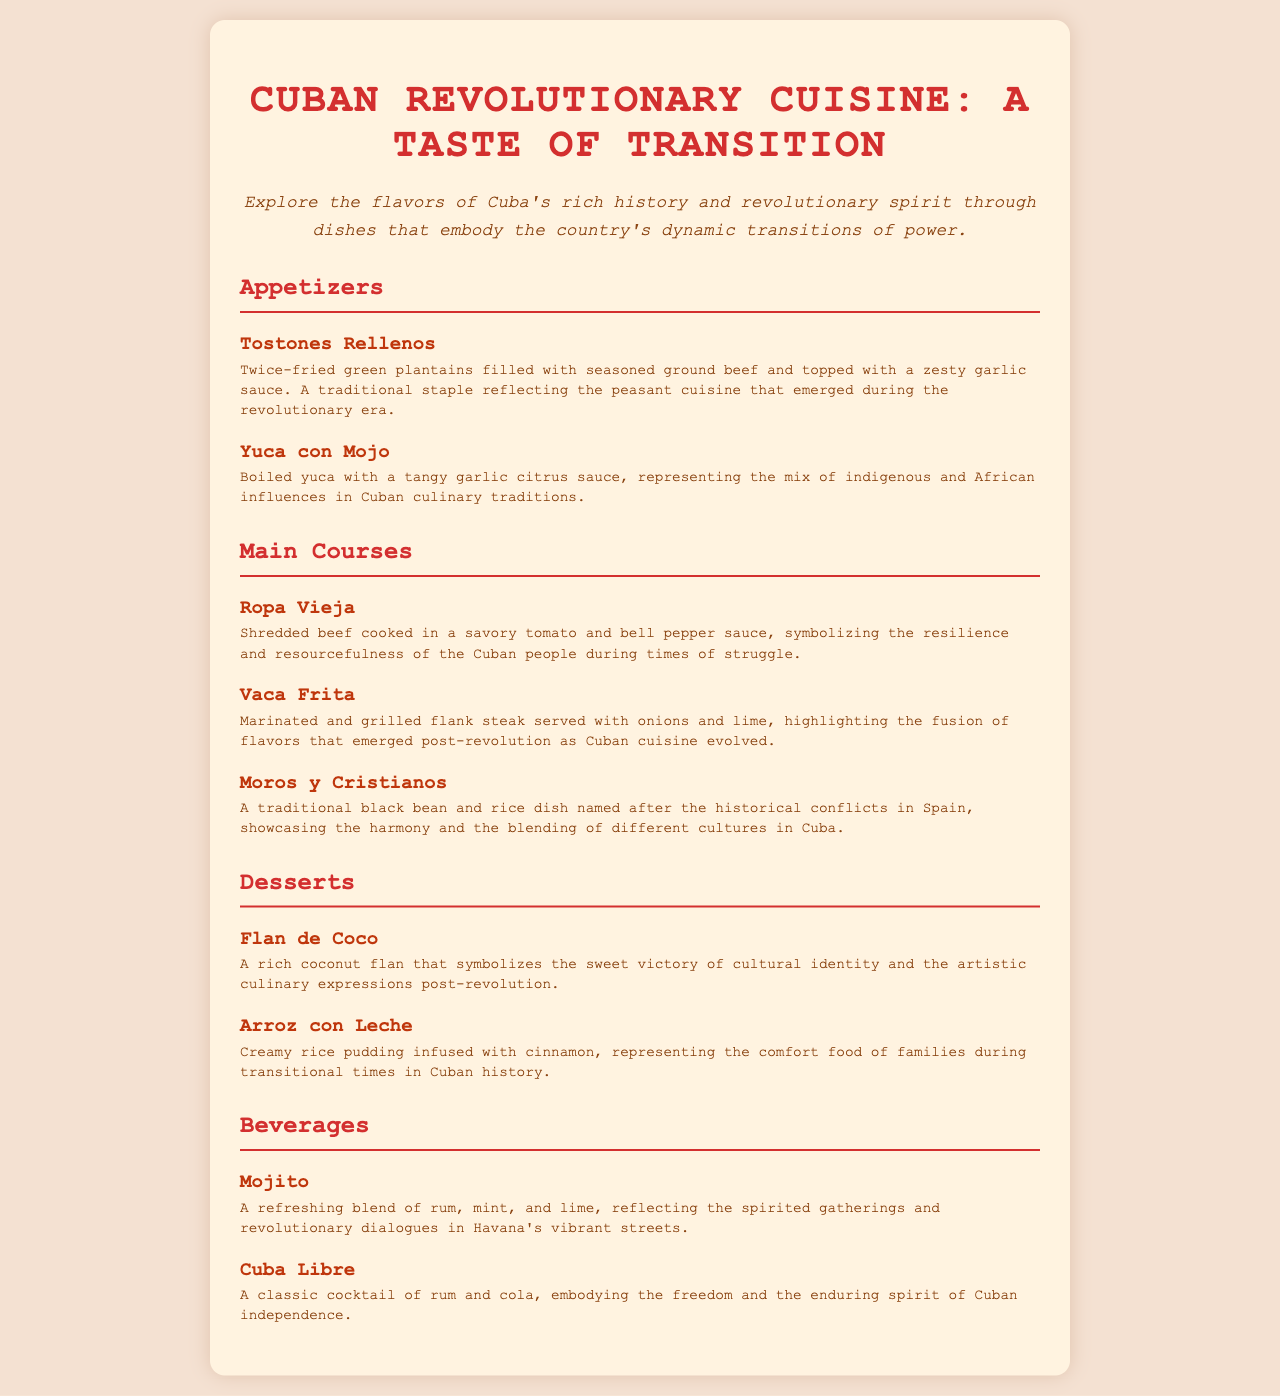¿Qué plato está hecho de plátanos verdes? El menú menciona "Tostones Rellenos", que son hechos de plátanos verdes.
Answer: Tostones Rellenos ¿Cuál es el ingrediente principal del "Ropa Vieja"? El "Ropa Vieja" está hecho de carne de res deshebrada.
Answer: Carne de res ¿Qué tipo de bebida se describe como un "refresco refrescante"? La bebida "Mojito" es descrita como un refresco refrescante.
Answer: Mojito ¿Cuál es el postre que representa la identidad cultural cubana? "Flan de Coco" simboliza la victoria de la identidad cultural.
Answer: Flan de Coco ¿Qué plato refleja la mezcla de influencias africanas e indígenas? "Yuca con Mojo" representa la mezcla de influencias indígenas y africanas.
Answer: Yuca con Mojo ¿Cuántos platos hay en la sección de aperitivos? Hay dos platos listados en la sección de aperitivos.
Answer: 2 ¿Qué plato se asocia con la comodidad familiar en tiempos de transición? "Arroz con Leche" se asocia con el confort de las familias.
Answer: Arroz con Leche ¿Cuál es el símbolo de la resistencia del pueblo cubano según el menú? "Ropa Vieja" simboliza la resistencia del pueblo cubano.
Answer: Ropa Vieja 